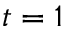<formula> <loc_0><loc_0><loc_500><loc_500>t = 1</formula> 